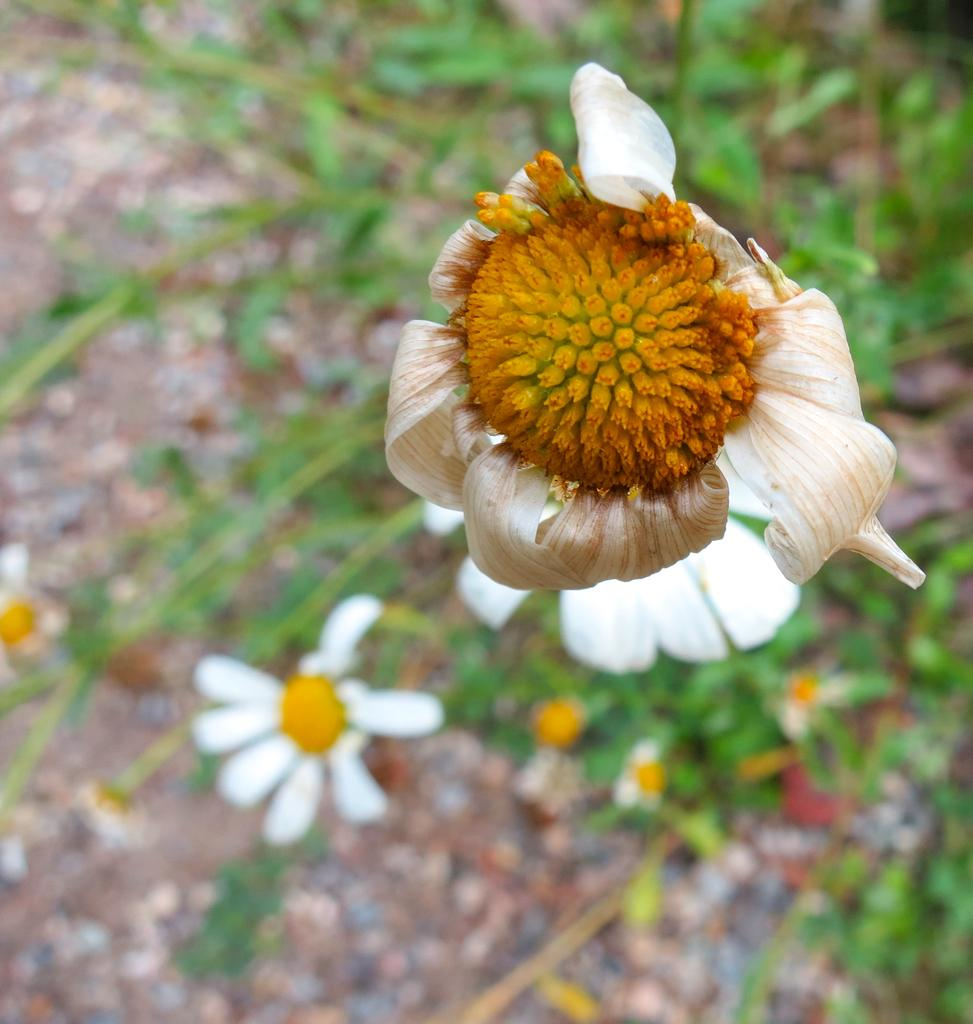What type of living organisms can be seen in the image? Plants can be seen in the image. What specific features do the plants have? The plants have flowers with white petals and a yellow center. How many people are pushing the cork in the image? There is no cork or people pushing it in the image; it features plants with flowers. 